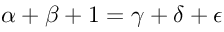Convert formula to latex. <formula><loc_0><loc_0><loc_500><loc_500>\alpha + \beta + 1 = \gamma + \delta + \epsilon</formula> 